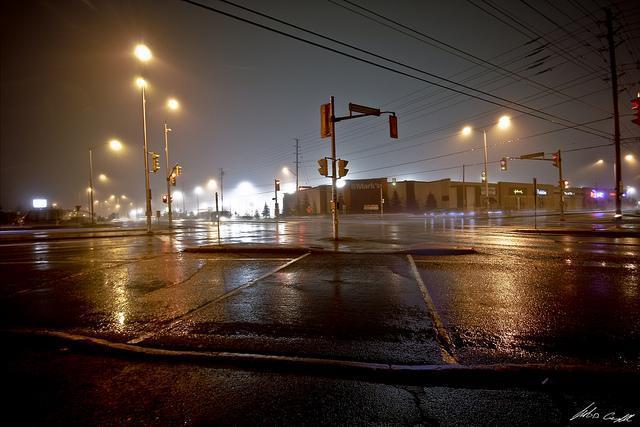How many people in the picture?
Give a very brief answer. 0. 